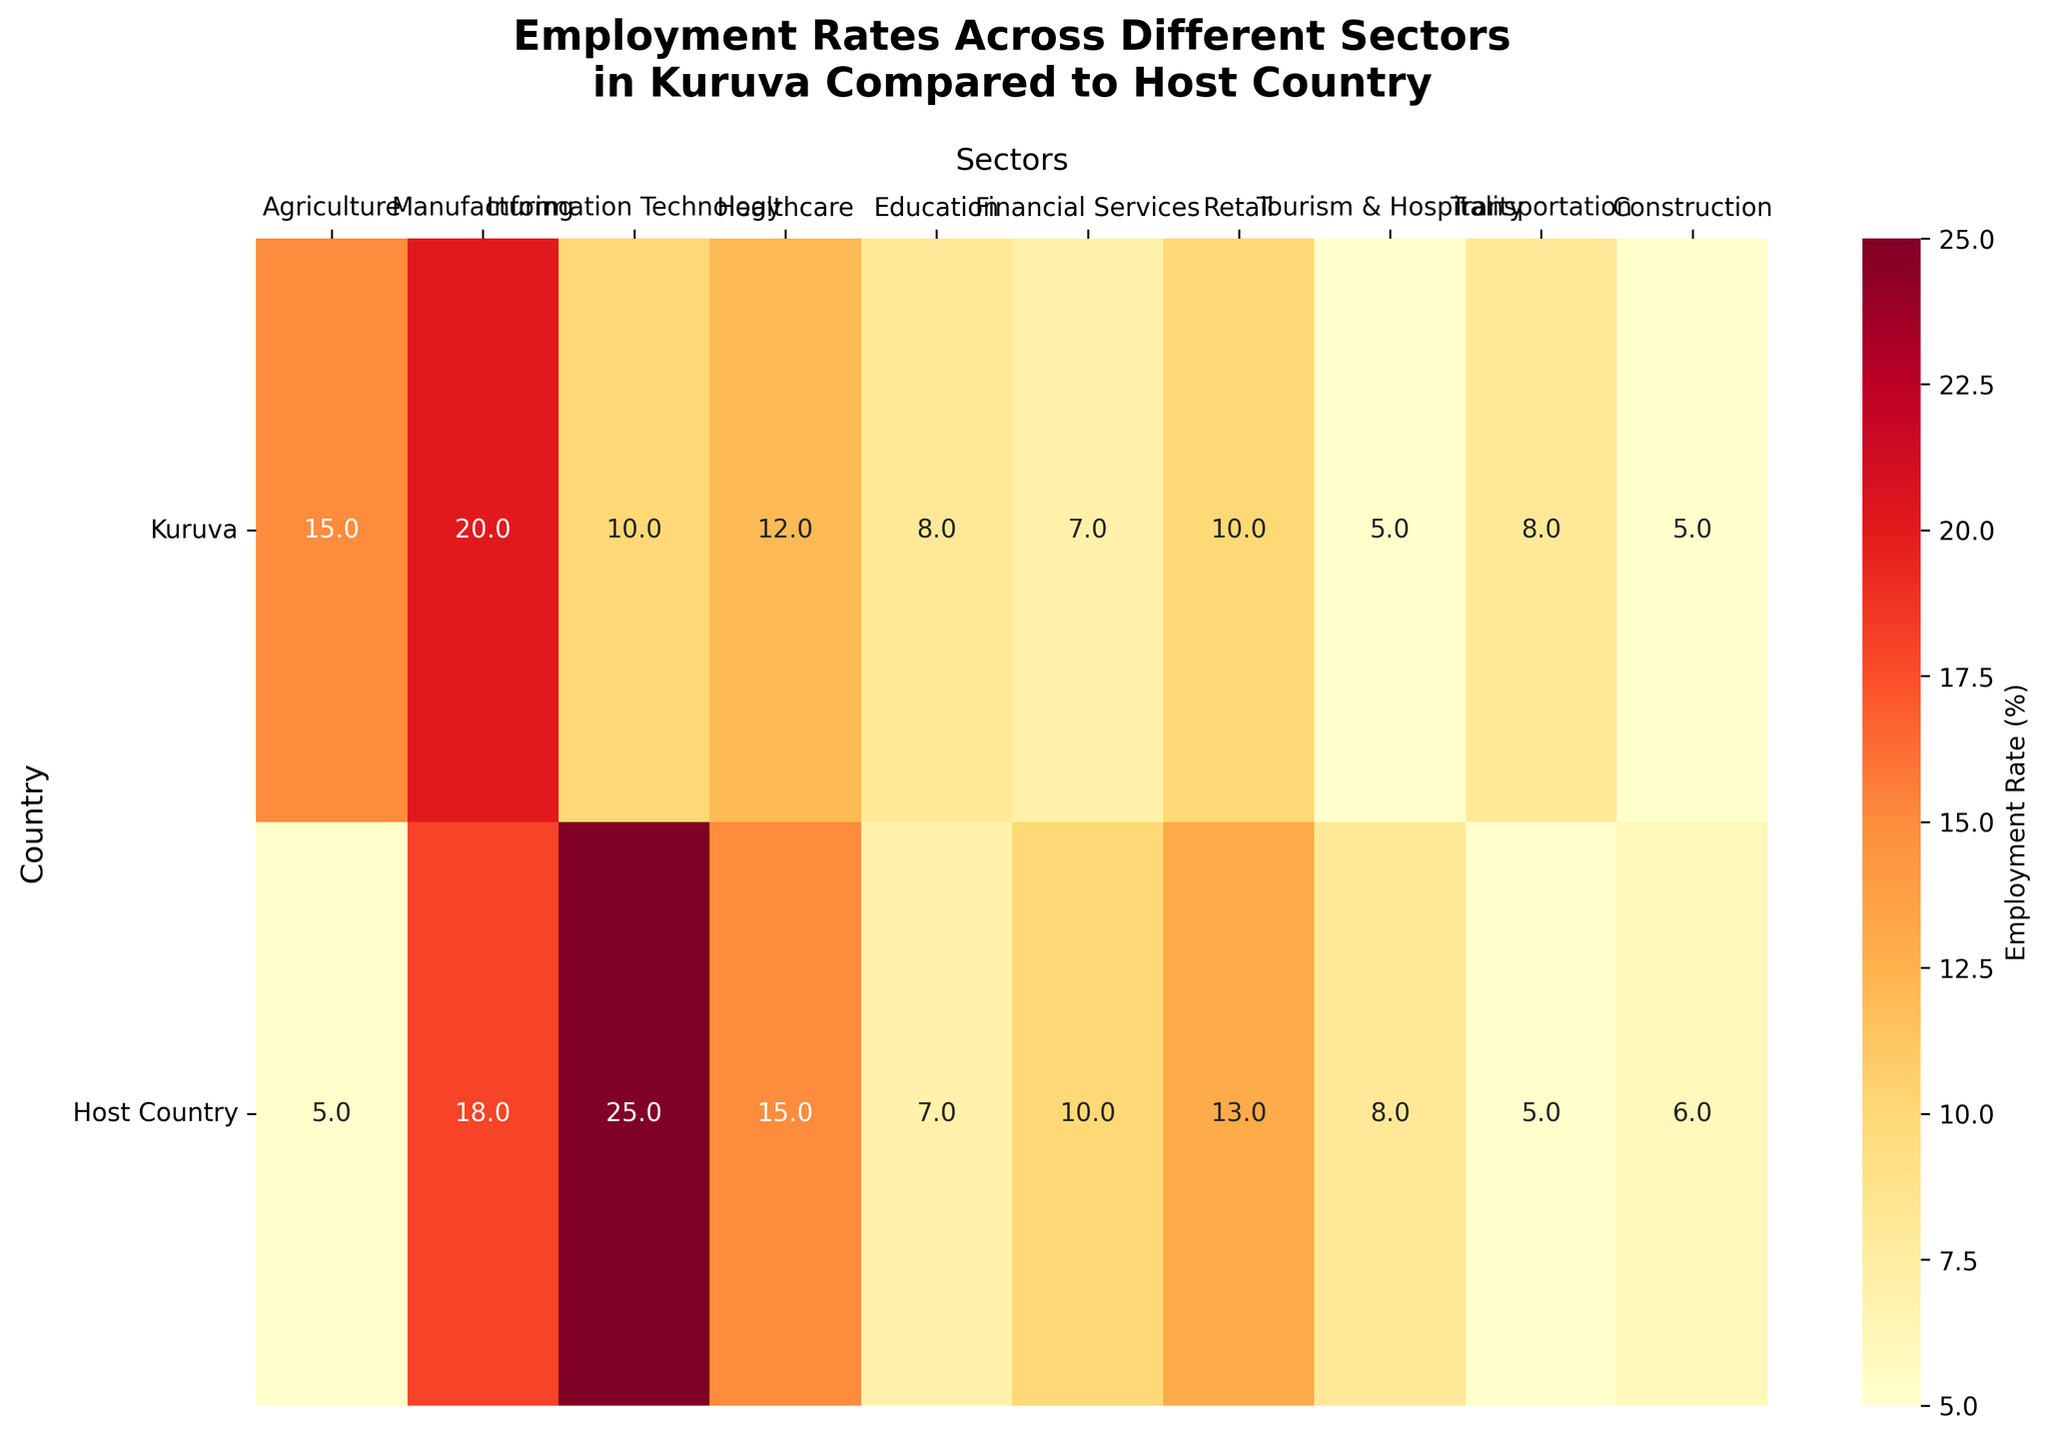What is the title of the figure? The title of the figure is located at the top in bold font and it summarizes the main insight the figure is conveying.
Answer: Employment Rates Across Different Sectors in Kuruva Compared to Host Country Which sector has the highest employment rate in Kuruva? By looking at the Kuruva row across all sectors, the highest percentage should be identified.
Answer: Manufacturing How does the employment rate in Agriculture compare between Kuruva and the host country? Find the employment rate for Agriculture in both rows and compare them. Kuruva has 15% and the host country has 5%.
Answer: Kuruva has higher employment in Agriculture What is the difference in employment rates in the IT sector between the two countries? Determine the values from the IT sector for both countries and calculate the difference: 25% (host country) - 10% (Kuruva) = 15%.
Answer: 15% What sectors have a higher employment rate in Kuruva compared to the host country? Identify sectors where the percentage in the Kuruva row exceeds the percentage in the host country row.
Answer: Agriculture, Transportation, Education, Manufacturing In which sector do Kuruva and the host country have the most similar employment rates? Find the sector where the difference between the employment rates of Kuruva and the host country is the smallest.
Answer: Education What is the average employment rate for Kuruva across all sectors? Sum all employment rates for Kuruva and divide by the number of sectors: (15+20+10+12+8+7+10+5+8+5)/10.
Answer: 10% Considering both countries, which sector has the lowest employment rate? Look for the smallest value across both Kuruva and the host country rows.
Answer: Construction How many sectors have employment rates within a 2% difference between Kuruva and the host country? Compare the employment rates of each sector for Kuruva and the host country and count those with a difference of 2% or less.
Answer: 2 sectors (Manufacturing and Education) Which sectors have the largest employment rate difference between Kuruva and the host country, and what is the value? Identify the sector with the largest gap by calculating the differences and finding the maximum: IT with
Answer: 15% 